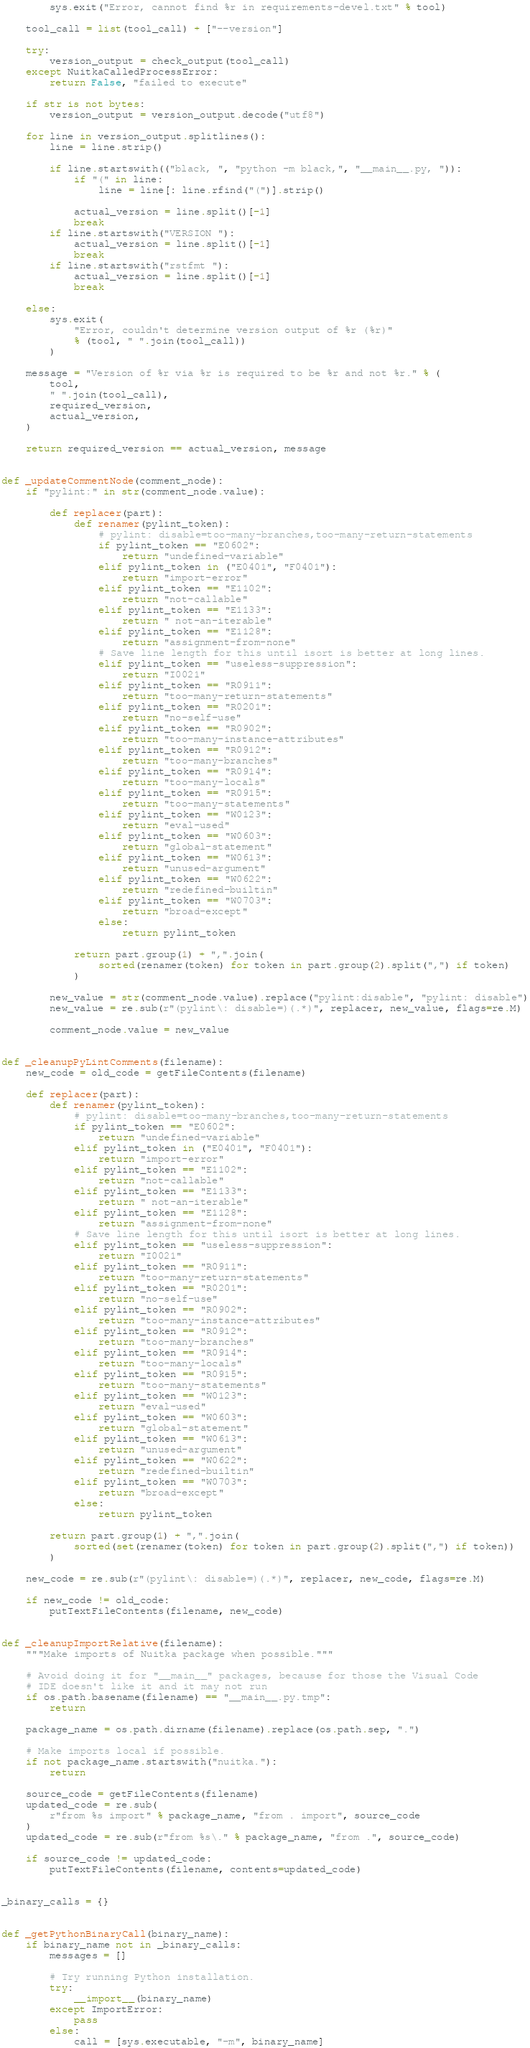<code> <loc_0><loc_0><loc_500><loc_500><_Python_>        sys.exit("Error, cannot find %r in requirements-devel.txt" % tool)

    tool_call = list(tool_call) + ["--version"]

    try:
        version_output = check_output(tool_call)
    except NuitkaCalledProcessError:
        return False, "failed to execute"

    if str is not bytes:
        version_output = version_output.decode("utf8")

    for line in version_output.splitlines():
        line = line.strip()

        if line.startswith(("black, ", "python -m black,", "__main__.py, ")):
            if "(" in line:
                line = line[: line.rfind("(")].strip()

            actual_version = line.split()[-1]
            break
        if line.startswith("VERSION "):
            actual_version = line.split()[-1]
            break
        if line.startswith("rstfmt "):
            actual_version = line.split()[-1]
            break

    else:
        sys.exit(
            "Error, couldn't determine version output of %r (%r)"
            % (tool, " ".join(tool_call))
        )

    message = "Version of %r via %r is required to be %r and not %r." % (
        tool,
        " ".join(tool_call),
        required_version,
        actual_version,
    )

    return required_version == actual_version, message


def _updateCommentNode(comment_node):
    if "pylint:" in str(comment_node.value):

        def replacer(part):
            def renamer(pylint_token):
                # pylint: disable=too-many-branches,too-many-return-statements
                if pylint_token == "E0602":
                    return "undefined-variable"
                elif pylint_token in ("E0401", "F0401"):
                    return "import-error"
                elif pylint_token == "E1102":
                    return "not-callable"
                elif pylint_token == "E1133":
                    return " not-an-iterable"
                elif pylint_token == "E1128":
                    return "assignment-from-none"
                # Save line length for this until isort is better at long lines.
                elif pylint_token == "useless-suppression":
                    return "I0021"
                elif pylint_token == "R0911":
                    return "too-many-return-statements"
                elif pylint_token == "R0201":
                    return "no-self-use"
                elif pylint_token == "R0902":
                    return "too-many-instance-attributes"
                elif pylint_token == "R0912":
                    return "too-many-branches"
                elif pylint_token == "R0914":
                    return "too-many-locals"
                elif pylint_token == "R0915":
                    return "too-many-statements"
                elif pylint_token == "W0123":
                    return "eval-used"
                elif pylint_token == "W0603":
                    return "global-statement"
                elif pylint_token == "W0613":
                    return "unused-argument"
                elif pylint_token == "W0622":
                    return "redefined-builtin"
                elif pylint_token == "W0703":
                    return "broad-except"
                else:
                    return pylint_token

            return part.group(1) + ",".join(
                sorted(renamer(token) for token in part.group(2).split(",") if token)
            )

        new_value = str(comment_node.value).replace("pylint:disable", "pylint: disable")
        new_value = re.sub(r"(pylint\: disable=)(.*)", replacer, new_value, flags=re.M)

        comment_node.value = new_value


def _cleanupPyLintComments(filename):
    new_code = old_code = getFileContents(filename)

    def replacer(part):
        def renamer(pylint_token):
            # pylint: disable=too-many-branches,too-many-return-statements
            if pylint_token == "E0602":
                return "undefined-variable"
            elif pylint_token in ("E0401", "F0401"):
                return "import-error"
            elif pylint_token == "E1102":
                return "not-callable"
            elif pylint_token == "E1133":
                return " not-an-iterable"
            elif pylint_token == "E1128":
                return "assignment-from-none"
            # Save line length for this until isort is better at long lines.
            elif pylint_token == "useless-suppression":
                return "I0021"
            elif pylint_token == "R0911":
                return "too-many-return-statements"
            elif pylint_token == "R0201":
                return "no-self-use"
            elif pylint_token == "R0902":
                return "too-many-instance-attributes"
            elif pylint_token == "R0912":
                return "too-many-branches"
            elif pylint_token == "R0914":
                return "too-many-locals"
            elif pylint_token == "R0915":
                return "too-many-statements"
            elif pylint_token == "W0123":
                return "eval-used"
            elif pylint_token == "W0603":
                return "global-statement"
            elif pylint_token == "W0613":
                return "unused-argument"
            elif pylint_token == "W0622":
                return "redefined-builtin"
            elif pylint_token == "W0703":
                return "broad-except"
            else:
                return pylint_token

        return part.group(1) + ",".join(
            sorted(set(renamer(token) for token in part.group(2).split(",") if token))
        )

    new_code = re.sub(r"(pylint\: disable=)(.*)", replacer, new_code, flags=re.M)

    if new_code != old_code:
        putTextFileContents(filename, new_code)


def _cleanupImportRelative(filename):
    """Make imports of Nuitka package when possible."""

    # Avoid doing it for "__main__" packages, because for those the Visual Code
    # IDE doesn't like it and it may not run
    if os.path.basename(filename) == "__main__.py.tmp":
        return

    package_name = os.path.dirname(filename).replace(os.path.sep, ".")

    # Make imports local if possible.
    if not package_name.startswith("nuitka."):
        return

    source_code = getFileContents(filename)
    updated_code = re.sub(
        r"from %s import" % package_name, "from . import", source_code
    )
    updated_code = re.sub(r"from %s\." % package_name, "from .", source_code)

    if source_code != updated_code:
        putTextFileContents(filename, contents=updated_code)


_binary_calls = {}


def _getPythonBinaryCall(binary_name):
    if binary_name not in _binary_calls:
        messages = []

        # Try running Python installation.
        try:
            __import__(binary_name)
        except ImportError:
            pass
        else:
            call = [sys.executable, "-m", binary_name]
</code> 